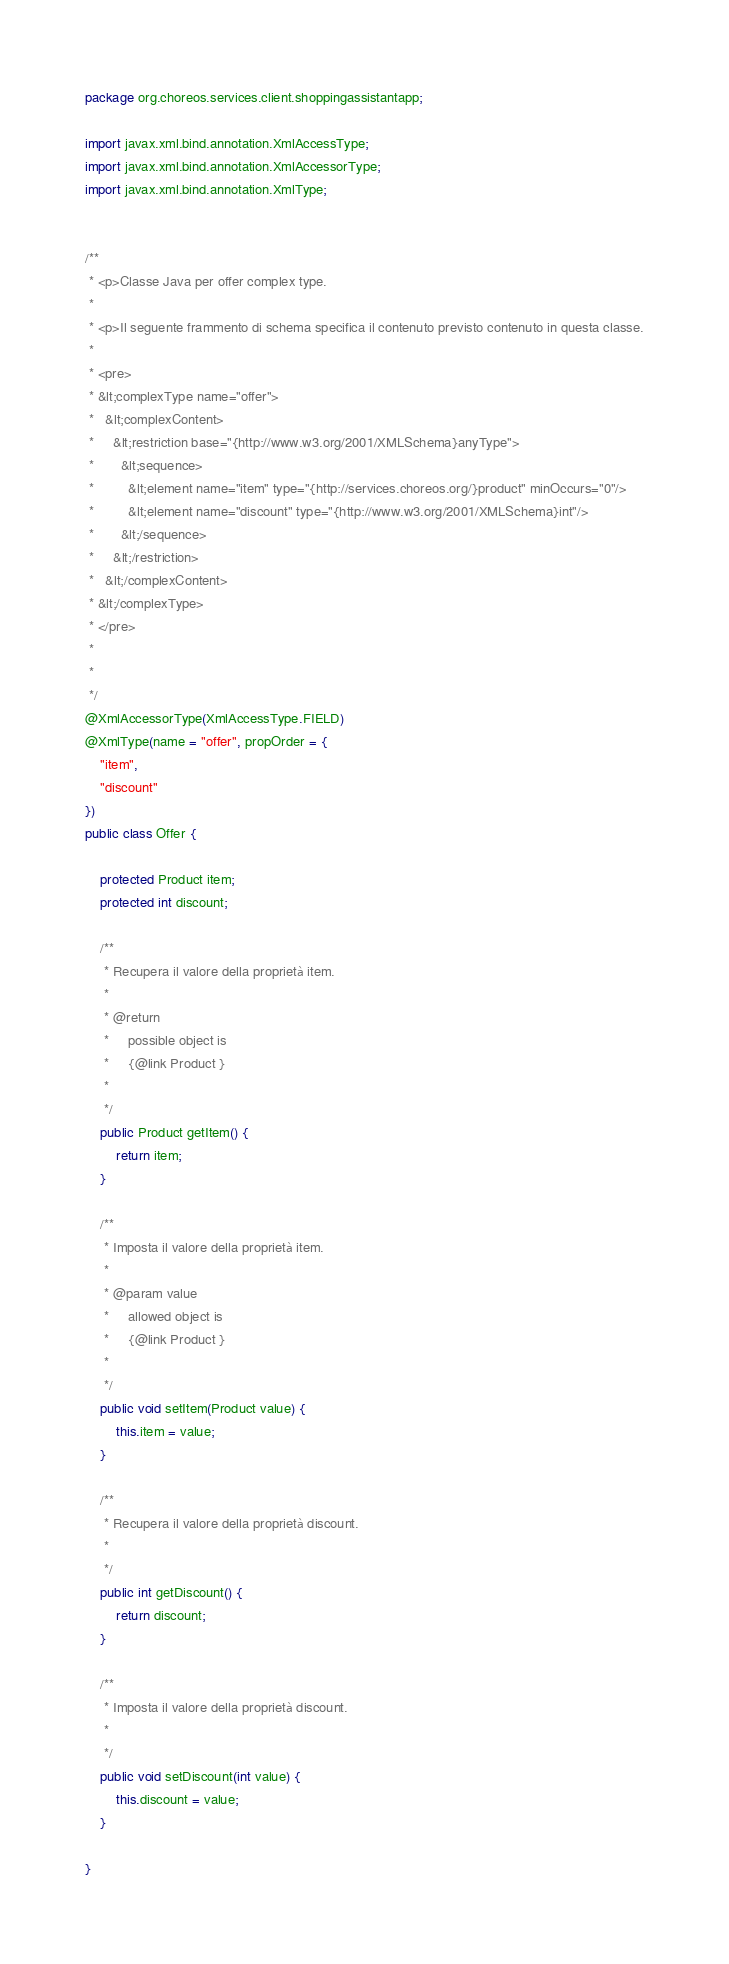Convert code to text. <code><loc_0><loc_0><loc_500><loc_500><_Java_>
package org.choreos.services.client.shoppingassistantapp;

import javax.xml.bind.annotation.XmlAccessType;
import javax.xml.bind.annotation.XmlAccessorType;
import javax.xml.bind.annotation.XmlType;


/**
 * <p>Classe Java per offer complex type.
 * 
 * <p>Il seguente frammento di schema specifica il contenuto previsto contenuto in questa classe.
 * 
 * <pre>
 * &lt;complexType name="offer">
 *   &lt;complexContent>
 *     &lt;restriction base="{http://www.w3.org/2001/XMLSchema}anyType">
 *       &lt;sequence>
 *         &lt;element name="item" type="{http://services.choreos.org/}product" minOccurs="0"/>
 *         &lt;element name="discount" type="{http://www.w3.org/2001/XMLSchema}int"/>
 *       &lt;/sequence>
 *     &lt;/restriction>
 *   &lt;/complexContent>
 * &lt;/complexType>
 * </pre>
 * 
 * 
 */
@XmlAccessorType(XmlAccessType.FIELD)
@XmlType(name = "offer", propOrder = {
    "item",
    "discount"
})
public class Offer {

    protected Product item;
    protected int discount;

    /**
     * Recupera il valore della proprietà item.
     * 
     * @return
     *     possible object is
     *     {@link Product }
     *     
     */
    public Product getItem() {
        return item;
    }

    /**
     * Imposta il valore della proprietà item.
     * 
     * @param value
     *     allowed object is
     *     {@link Product }
     *     
     */
    public void setItem(Product value) {
        this.item = value;
    }

    /**
     * Recupera il valore della proprietà discount.
     * 
     */
    public int getDiscount() {
        return discount;
    }

    /**
     * Imposta il valore della proprietà discount.
     * 
     */
    public void setDiscount(int value) {
        this.discount = value;
    }

}
</code> 